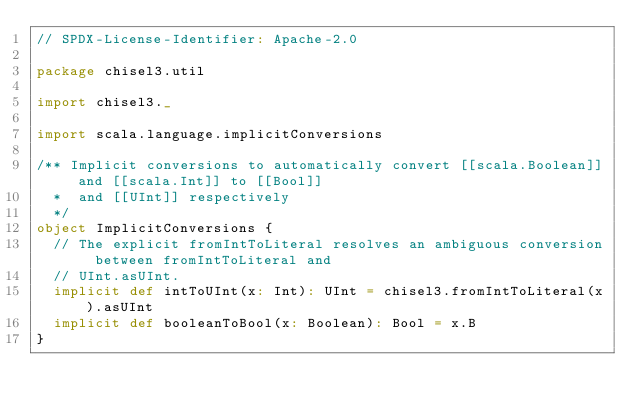<code> <loc_0><loc_0><loc_500><loc_500><_Scala_>// SPDX-License-Identifier: Apache-2.0

package chisel3.util

import chisel3._

import scala.language.implicitConversions

/** Implicit conversions to automatically convert [[scala.Boolean]] and [[scala.Int]] to [[Bool]]
  *  and [[UInt]] respectively
  */
object ImplicitConversions {
  // The explicit fromIntToLiteral resolves an ambiguous conversion between fromIntToLiteral and
  // UInt.asUInt.
  implicit def intToUInt(x: Int): UInt = chisel3.fromIntToLiteral(x).asUInt
  implicit def booleanToBool(x: Boolean): Bool = x.B
}
</code> 